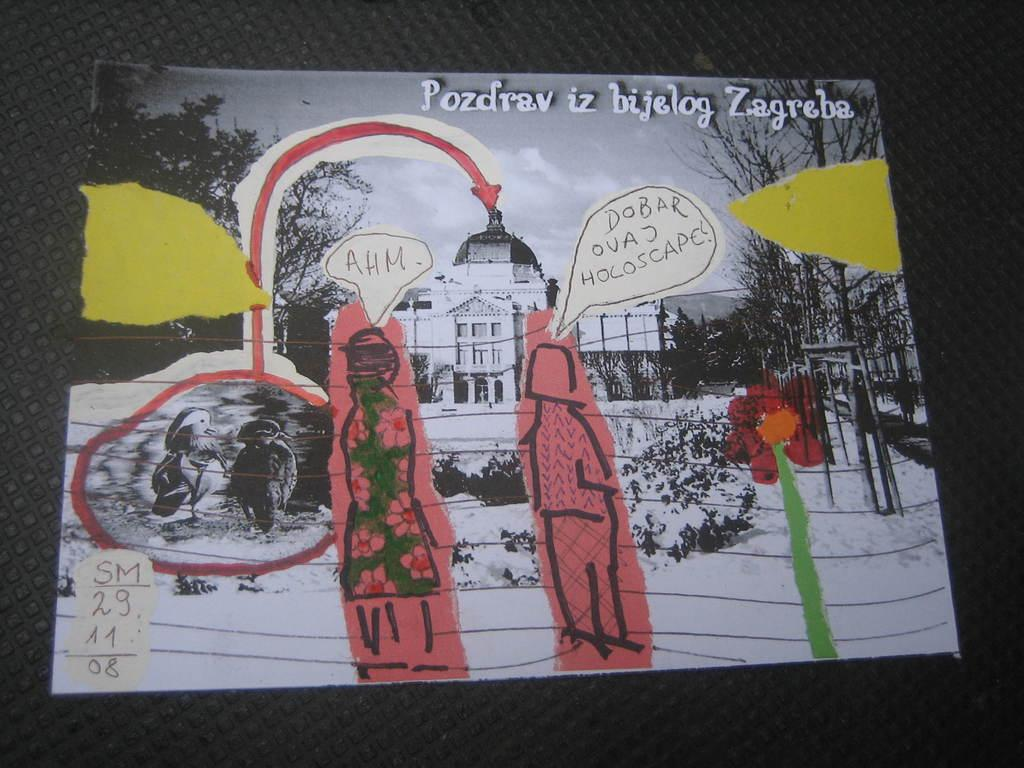What is featured on the black surface in the image? There is a poster on the black surface in the image. What can be seen on the poster? There is writing on the poster. What type of drawings are present in the image? There are drawings of trees, buildings, and other drawings in the image. How is the glue used in the image? There is no glue present in the image. What type of emotion is expressed by the drawings in the image? The provided facts do not mention any emotions associated with the drawings in the image. 